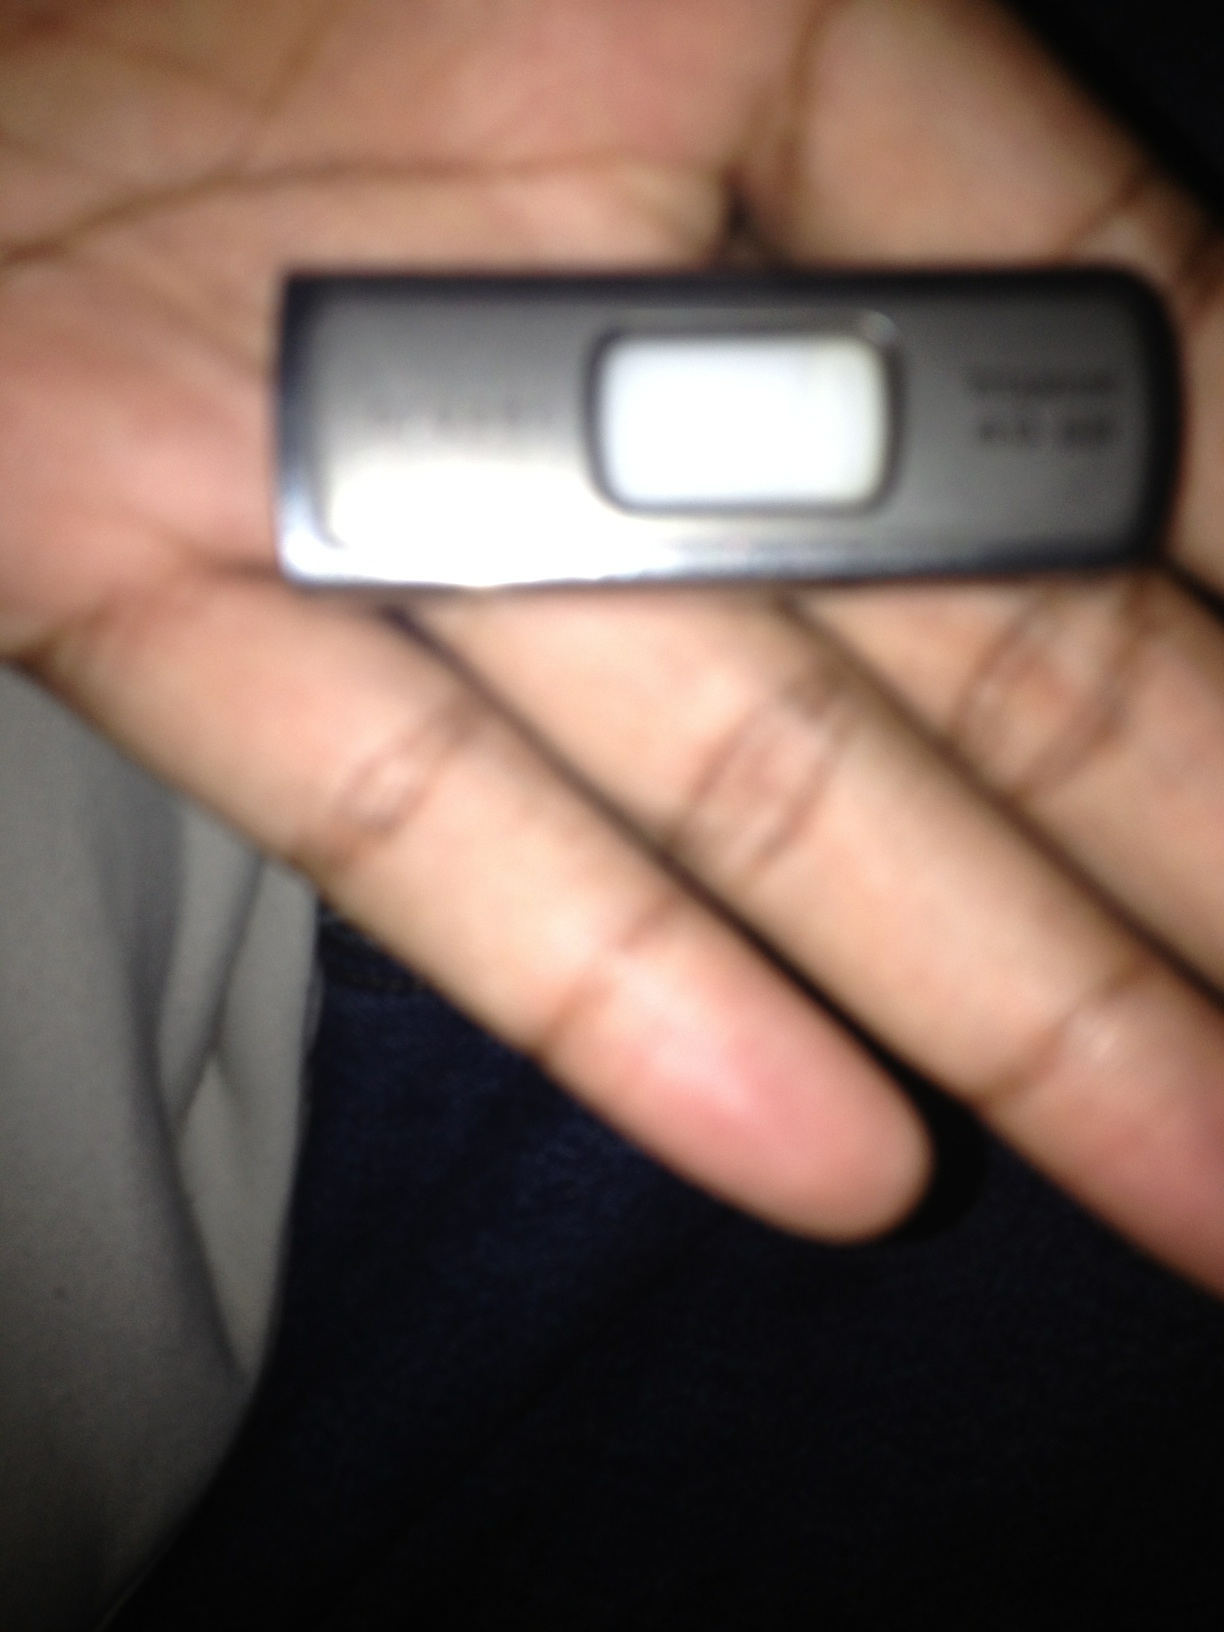Why might a person choose to use a flash drive over cloud storage services? A person might choose to use a flash drive over cloud storage services for several reasons: 

1. **Accessibility:** A flash drive can be accessed without an internet connection, making it a reliable option in areas with poor or no internet connectivity. 
2. **Speed:** Transferring large files to and from a flash drive can be faster than uploading or downloading from the cloud, especially with high-speed USB ports. 
3. **Security:** Some users may prefer the physical security of a flash drive, avoiding potential security risks associated with cloud storage services. 
4. **Control:** Having complete control over the physical drive means the user can determine exactly where and how their data is stored and transferred, potentially reducing risks of data breaches or unauthorized access. 
5. **Cost:** For large amounts of storage, a one-time purchase of a high-capacity flash drive can be more economical than paying for ongoing cloud storage subscriptions. 